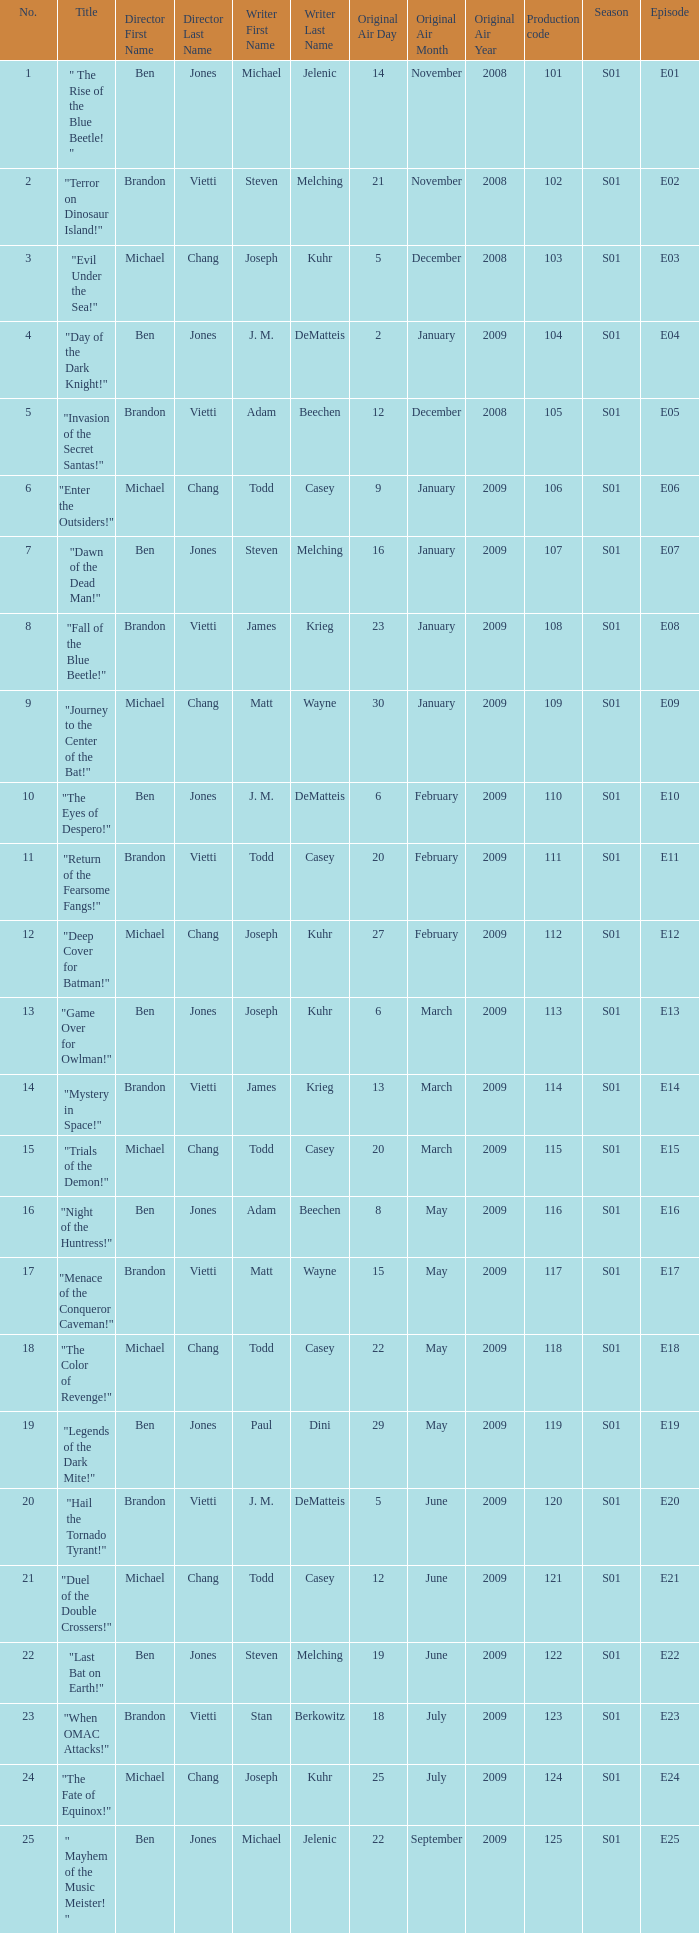What is the the television order of "deep cover for batman!" S01E12. 